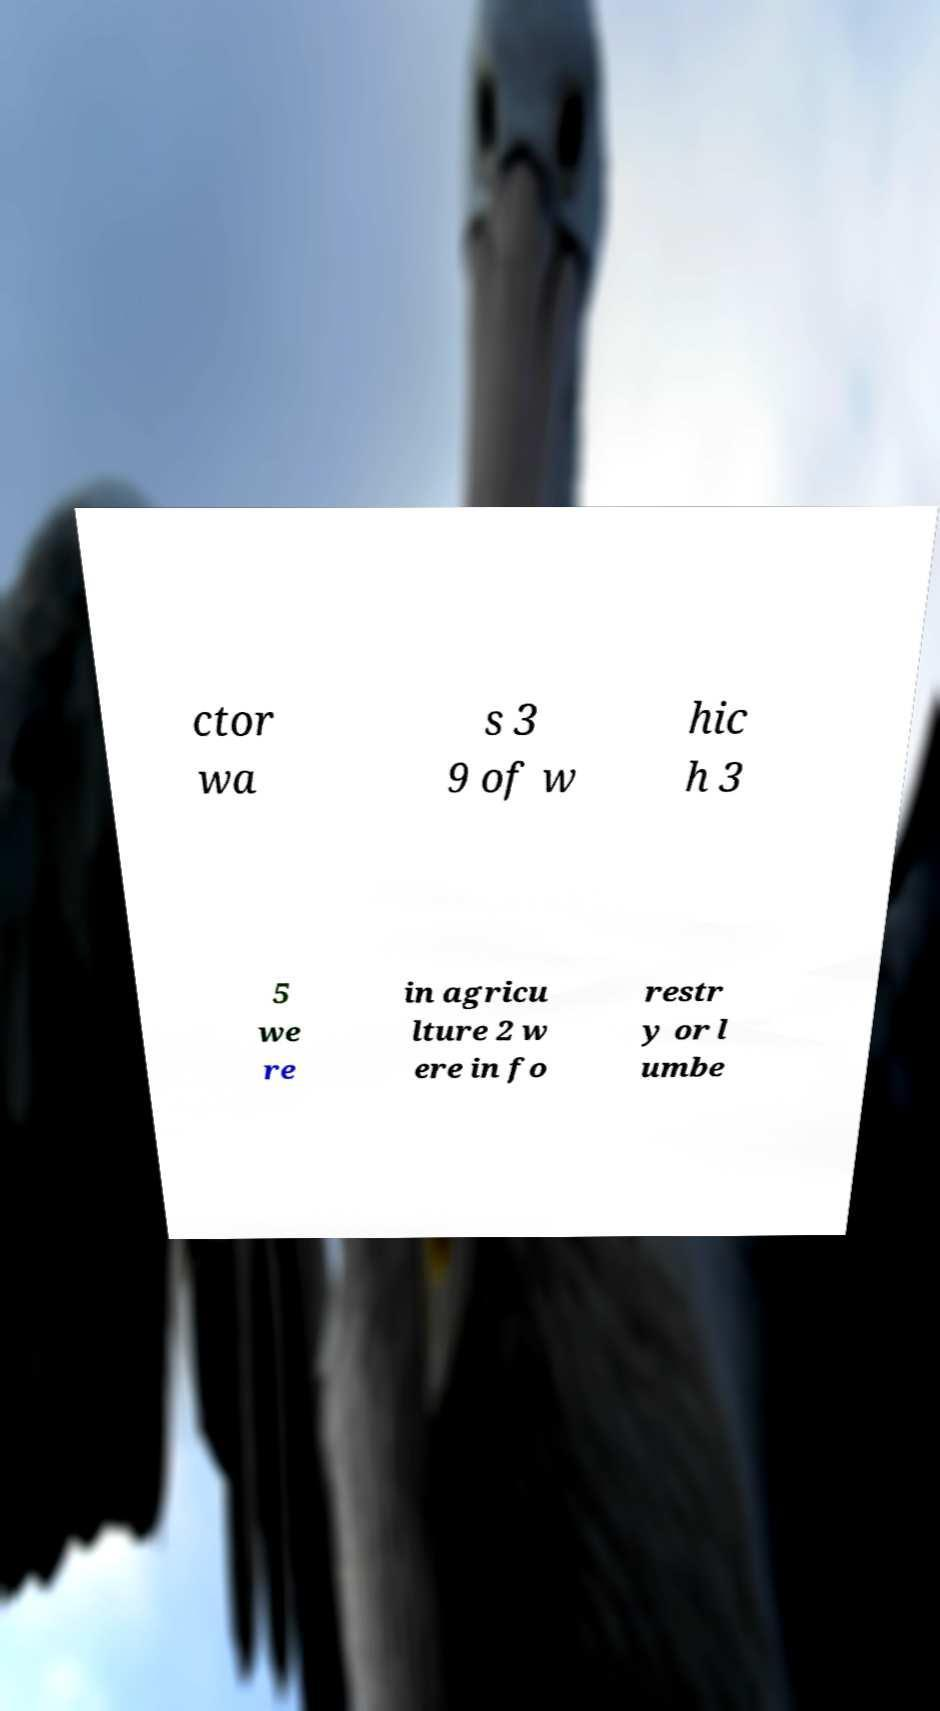Please identify and transcribe the text found in this image. ctor wa s 3 9 of w hic h 3 5 we re in agricu lture 2 w ere in fo restr y or l umbe 